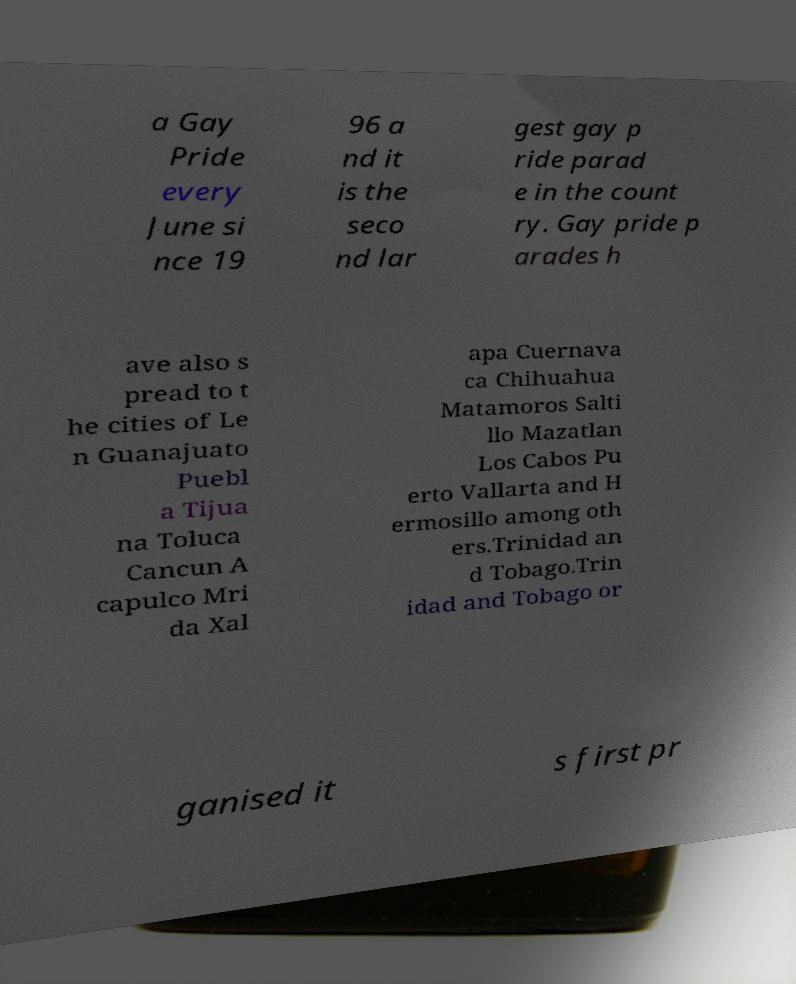Please identify and transcribe the text found in this image. a Gay Pride every June si nce 19 96 a nd it is the seco nd lar gest gay p ride parad e in the count ry. Gay pride p arades h ave also s pread to t he cities of Le n Guanajuato Puebl a Tijua na Toluca Cancun A capulco Mri da Xal apa Cuernava ca Chihuahua Matamoros Salti llo Mazatlan Los Cabos Pu erto Vallarta and H ermosillo among oth ers.Trinidad an d Tobago.Trin idad and Tobago or ganised it s first pr 